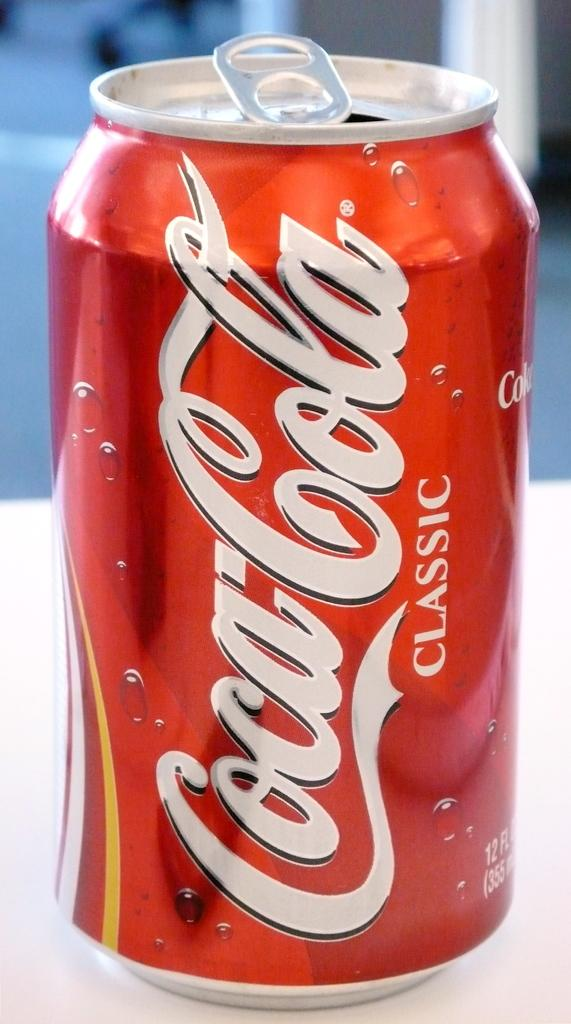Provide a one-sentence caption for the provided image. A small red coke can that is open. 